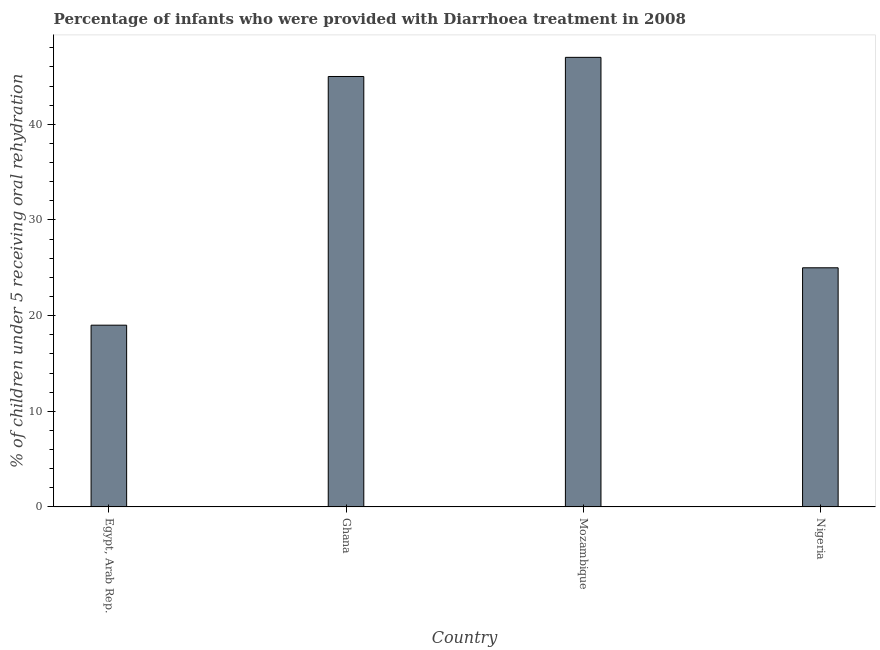Does the graph contain any zero values?
Your response must be concise. No. What is the title of the graph?
Ensure brevity in your answer.  Percentage of infants who were provided with Diarrhoea treatment in 2008. What is the label or title of the Y-axis?
Keep it short and to the point. % of children under 5 receiving oral rehydration. Across all countries, what is the maximum percentage of children who were provided with treatment diarrhoea?
Your answer should be very brief. 47. Across all countries, what is the minimum percentage of children who were provided with treatment diarrhoea?
Provide a succinct answer. 19. In which country was the percentage of children who were provided with treatment diarrhoea maximum?
Your answer should be very brief. Mozambique. In which country was the percentage of children who were provided with treatment diarrhoea minimum?
Ensure brevity in your answer.  Egypt, Arab Rep. What is the sum of the percentage of children who were provided with treatment diarrhoea?
Your response must be concise. 136. What is the difference between the percentage of children who were provided with treatment diarrhoea in Ghana and Nigeria?
Your answer should be compact. 20. What is the average percentage of children who were provided with treatment diarrhoea per country?
Provide a succinct answer. 34. In how many countries, is the percentage of children who were provided with treatment diarrhoea greater than 30 %?
Give a very brief answer. 2. Is the difference between the percentage of children who were provided with treatment diarrhoea in Mozambique and Nigeria greater than the difference between any two countries?
Provide a succinct answer. No. What is the difference between the highest and the second highest percentage of children who were provided with treatment diarrhoea?
Offer a terse response. 2. Is the sum of the percentage of children who were provided with treatment diarrhoea in Egypt, Arab Rep. and Ghana greater than the maximum percentage of children who were provided with treatment diarrhoea across all countries?
Your answer should be very brief. Yes. How many bars are there?
Give a very brief answer. 4. How many countries are there in the graph?
Keep it short and to the point. 4. Are the values on the major ticks of Y-axis written in scientific E-notation?
Your answer should be very brief. No. What is the % of children under 5 receiving oral rehydration of Egypt, Arab Rep.?
Provide a succinct answer. 19. What is the % of children under 5 receiving oral rehydration in Mozambique?
Your response must be concise. 47. What is the difference between the % of children under 5 receiving oral rehydration in Egypt, Arab Rep. and Ghana?
Ensure brevity in your answer.  -26. What is the difference between the % of children under 5 receiving oral rehydration in Egypt, Arab Rep. and Nigeria?
Give a very brief answer. -6. What is the difference between the % of children under 5 receiving oral rehydration in Ghana and Mozambique?
Your answer should be compact. -2. What is the difference between the % of children under 5 receiving oral rehydration in Ghana and Nigeria?
Keep it short and to the point. 20. What is the difference between the % of children under 5 receiving oral rehydration in Mozambique and Nigeria?
Your response must be concise. 22. What is the ratio of the % of children under 5 receiving oral rehydration in Egypt, Arab Rep. to that in Ghana?
Offer a terse response. 0.42. What is the ratio of the % of children under 5 receiving oral rehydration in Egypt, Arab Rep. to that in Mozambique?
Keep it short and to the point. 0.4. What is the ratio of the % of children under 5 receiving oral rehydration in Egypt, Arab Rep. to that in Nigeria?
Provide a succinct answer. 0.76. What is the ratio of the % of children under 5 receiving oral rehydration in Ghana to that in Mozambique?
Offer a terse response. 0.96. What is the ratio of the % of children under 5 receiving oral rehydration in Mozambique to that in Nigeria?
Offer a terse response. 1.88. 